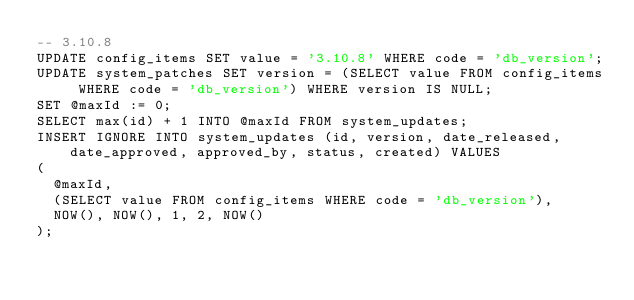Convert code to text. <code><loc_0><loc_0><loc_500><loc_500><_SQL_>-- 3.10.8
UPDATE config_items SET value = '3.10.8' WHERE code = 'db_version';
UPDATE system_patches SET version = (SELECT value FROM config_items WHERE code = 'db_version') WHERE version IS NULL;
SET @maxId := 0;
SELECT max(id) + 1 INTO @maxId FROM system_updates;
INSERT IGNORE INTO system_updates (id, version, date_released, date_approved, approved_by, status, created) VALUES
(
  @maxId,
  (SELECT value FROM config_items WHERE code = 'db_version'),
  NOW(), NOW(), 1, 2, NOW()
);
</code> 